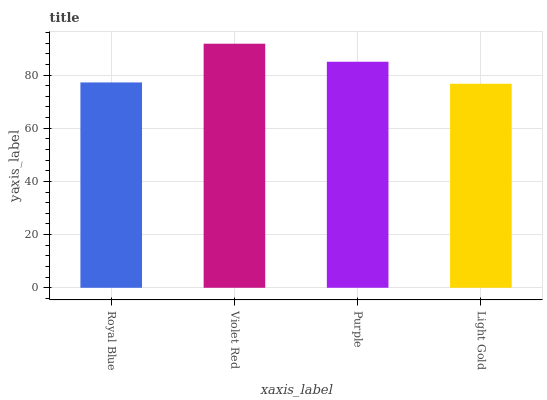Is Light Gold the minimum?
Answer yes or no. Yes. Is Violet Red the maximum?
Answer yes or no. Yes. Is Purple the minimum?
Answer yes or no. No. Is Purple the maximum?
Answer yes or no. No. Is Violet Red greater than Purple?
Answer yes or no. Yes. Is Purple less than Violet Red?
Answer yes or no. Yes. Is Purple greater than Violet Red?
Answer yes or no. No. Is Violet Red less than Purple?
Answer yes or no. No. Is Purple the high median?
Answer yes or no. Yes. Is Royal Blue the low median?
Answer yes or no. Yes. Is Light Gold the high median?
Answer yes or no. No. Is Light Gold the low median?
Answer yes or no. No. 